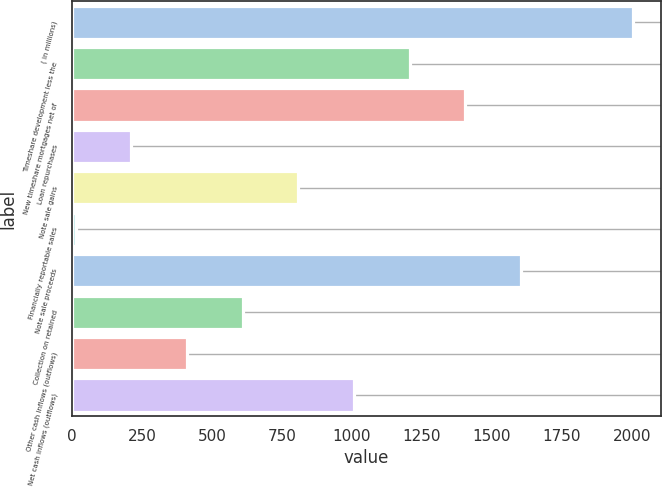Convert chart to OTSL. <chart><loc_0><loc_0><loc_500><loc_500><bar_chart><fcel>( in millions)<fcel>Timeshare development less the<fcel>New timeshare mortgages net of<fcel>Loan repurchases<fcel>Note sale gains<fcel>Financially reportable sales<fcel>Note sale proceeds<fcel>Collection on retained<fcel>Other cash inflows (outflows)<fcel>Net cash inflows (outflows)<nl><fcel>2002<fcel>1206.4<fcel>1405.3<fcel>211.9<fcel>808.6<fcel>13<fcel>1604.2<fcel>609.7<fcel>410.8<fcel>1007.5<nl></chart> 